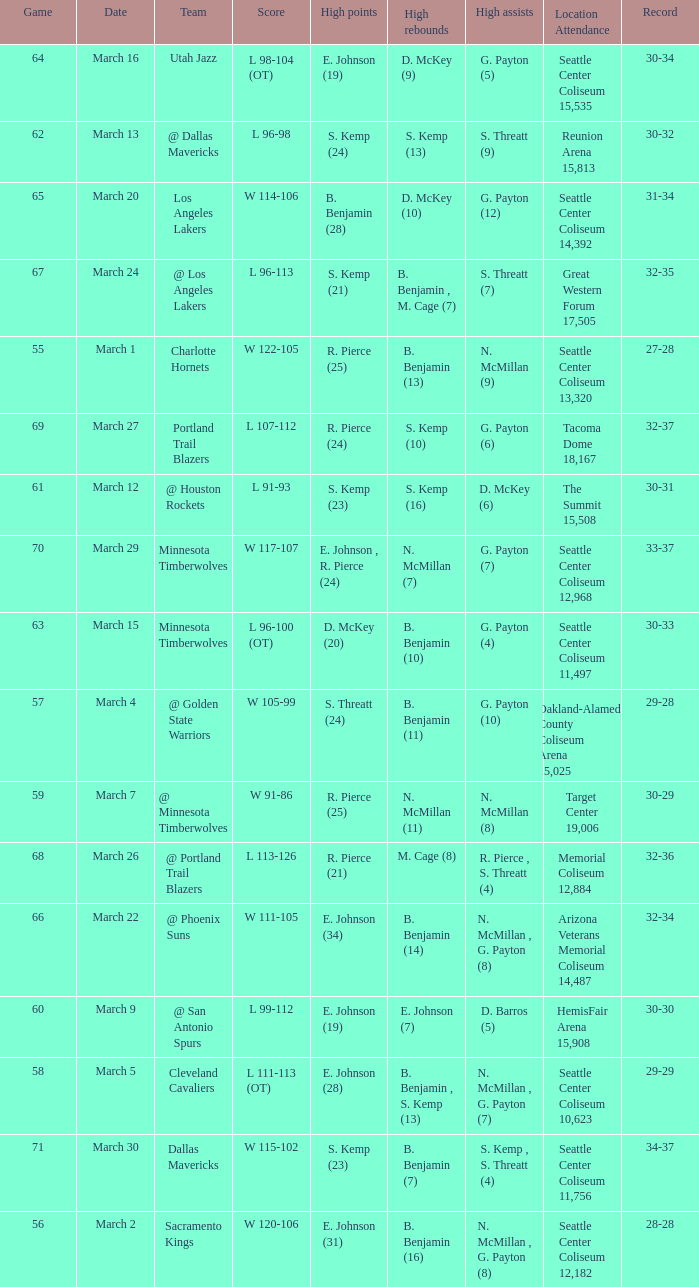Write the full table. {'header': ['Game', 'Date', 'Team', 'Score', 'High points', 'High rebounds', 'High assists', 'Location Attendance', 'Record'], 'rows': [['64', 'March 16', 'Utah Jazz', 'L 98-104 (OT)', 'E. Johnson (19)', 'D. McKey (9)', 'G. Payton (5)', 'Seattle Center Coliseum 15,535', '30-34'], ['62', 'March 13', '@ Dallas Mavericks', 'L 96-98', 'S. Kemp (24)', 'S. Kemp (13)', 'S. Threatt (9)', 'Reunion Arena 15,813', '30-32'], ['65', 'March 20', 'Los Angeles Lakers', 'W 114-106', 'B. Benjamin (28)', 'D. McKey (10)', 'G. Payton (12)', 'Seattle Center Coliseum 14,392', '31-34'], ['67', 'March 24', '@ Los Angeles Lakers', 'L 96-113', 'S. Kemp (21)', 'B. Benjamin , M. Cage (7)', 'S. Threatt (7)', 'Great Western Forum 17,505', '32-35'], ['55', 'March 1', 'Charlotte Hornets', 'W 122-105', 'R. Pierce (25)', 'B. Benjamin (13)', 'N. McMillan (9)', 'Seattle Center Coliseum 13,320', '27-28'], ['69', 'March 27', 'Portland Trail Blazers', 'L 107-112', 'R. Pierce (24)', 'S. Kemp (10)', 'G. Payton (6)', 'Tacoma Dome 18,167', '32-37'], ['61', 'March 12', '@ Houston Rockets', 'L 91-93', 'S. Kemp (23)', 'S. Kemp (16)', 'D. McKey (6)', 'The Summit 15,508', '30-31'], ['70', 'March 29', 'Minnesota Timberwolves', 'W 117-107', 'E. Johnson , R. Pierce (24)', 'N. McMillan (7)', 'G. Payton (7)', 'Seattle Center Coliseum 12,968', '33-37'], ['63', 'March 15', 'Minnesota Timberwolves', 'L 96-100 (OT)', 'D. McKey (20)', 'B. Benjamin (10)', 'G. Payton (4)', 'Seattle Center Coliseum 11,497', '30-33'], ['57', 'March 4', '@ Golden State Warriors', 'W 105-99', 'S. Threatt (24)', 'B. Benjamin (11)', 'G. Payton (10)', 'Oakland-Alameda County Coliseum Arena 15,025', '29-28'], ['59', 'March 7', '@ Minnesota Timberwolves', 'W 91-86', 'R. Pierce (25)', 'N. McMillan (11)', 'N. McMillan (8)', 'Target Center 19,006', '30-29'], ['68', 'March 26', '@ Portland Trail Blazers', 'L 113-126', 'R. Pierce (21)', 'M. Cage (8)', 'R. Pierce , S. Threatt (4)', 'Memorial Coliseum 12,884', '32-36'], ['66', 'March 22', '@ Phoenix Suns', 'W 111-105', 'E. Johnson (34)', 'B. Benjamin (14)', 'N. McMillan , G. Payton (8)', 'Arizona Veterans Memorial Coliseum 14,487', '32-34'], ['60', 'March 9', '@ San Antonio Spurs', 'L 99-112', 'E. Johnson (19)', 'E. Johnson (7)', 'D. Barros (5)', 'HemisFair Arena 15,908', '30-30'], ['58', 'March 5', 'Cleveland Cavaliers', 'L 111-113 (OT)', 'E. Johnson (28)', 'B. Benjamin , S. Kemp (13)', 'N. McMillan , G. Payton (7)', 'Seattle Center Coliseum 10,623', '29-29'], ['71', 'March 30', 'Dallas Mavericks', 'W 115-102', 'S. Kemp (23)', 'B. Benjamin (7)', 'S. Kemp , S. Threatt (4)', 'Seattle Center Coliseum 11,756', '34-37'], ['56', 'March 2', 'Sacramento Kings', 'W 120-106', 'E. Johnson (31)', 'B. Benjamin (16)', 'N. McMillan , G. Payton (8)', 'Seattle Center Coliseum 12,182', '28-28']]} Which game was played on march 2? 56.0. 